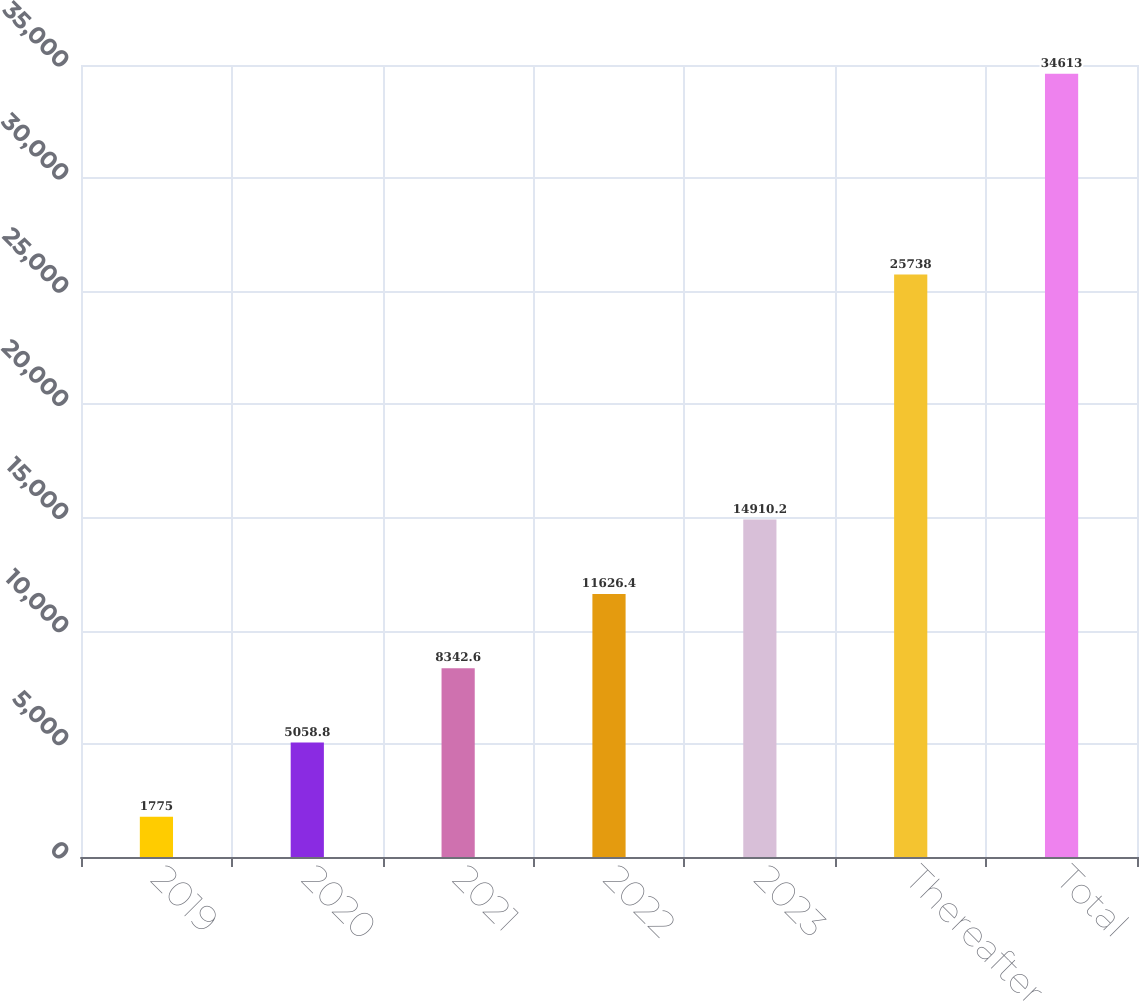<chart> <loc_0><loc_0><loc_500><loc_500><bar_chart><fcel>2019<fcel>2020<fcel>2021<fcel>2022<fcel>2023<fcel>Thereafter<fcel>Total<nl><fcel>1775<fcel>5058.8<fcel>8342.6<fcel>11626.4<fcel>14910.2<fcel>25738<fcel>34613<nl></chart> 